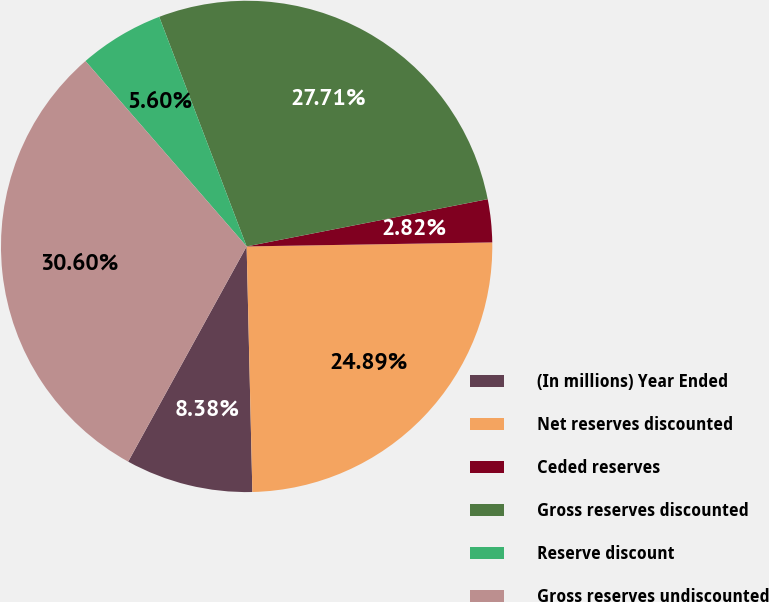Convert chart to OTSL. <chart><loc_0><loc_0><loc_500><loc_500><pie_chart><fcel>(In millions) Year Ended<fcel>Net reserves discounted<fcel>Ceded reserves<fcel>Gross reserves discounted<fcel>Reserve discount<fcel>Gross reserves undiscounted<nl><fcel>8.38%<fcel>24.89%<fcel>2.82%<fcel>27.71%<fcel>5.6%<fcel>30.6%<nl></chart> 